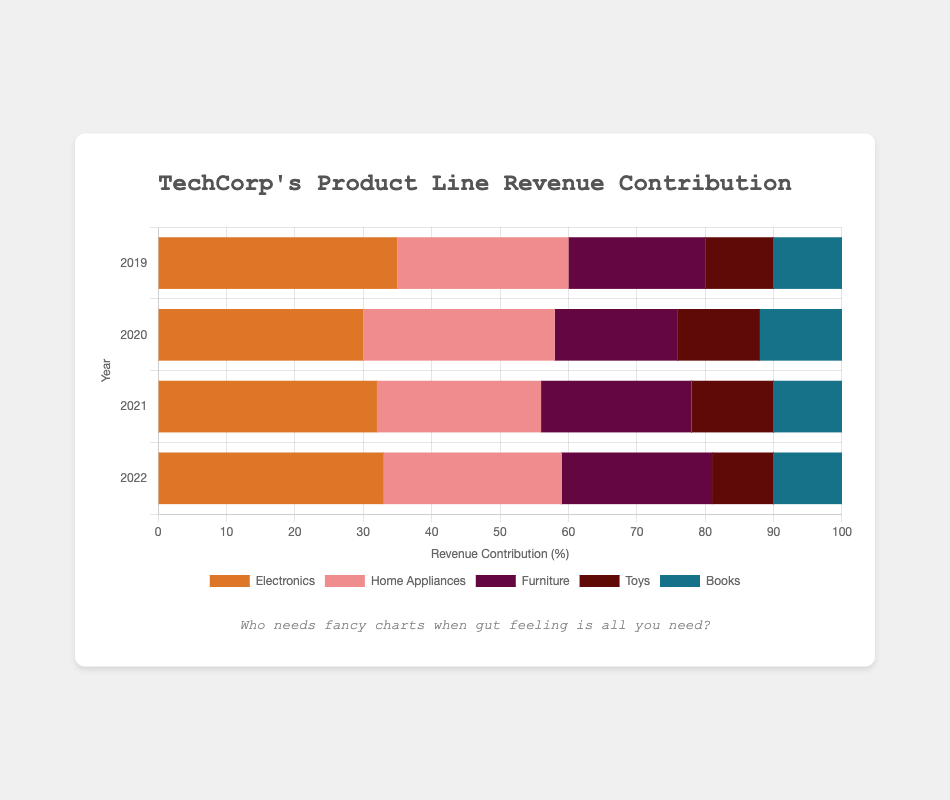Which product line had the highest revenue contribution in 2019? The figure shows that in 2019, the Electronics product line had the highest revenue contribution. This can be identified by the length of the bar representing Electronics in 2019, which is the longest among all product lines.
Answer: Electronics Which year had the highest total revenue contribution from the Toys product line? By examining the length of the Toys bar across the years, 2020 and 2021 have the longest bars at 12%. Since the values are equal, both years had the highest contribution for Toys.
Answer: 2020 and 2021 What is the total revenue contribution of Electronics and Furniture product lines in 2022? To find the total revenue contribution for 2022, add the percentage contributions of Electronics (33%) and Furniture (22%) for 2022. This equals 33 + 22 = 55%.
Answer: 55% Which product line experienced an increase in revenue contribution from 2019 to 2020? By comparing the lengths of bars for each product line from 2019 to 2020, Home Appliances shows an increase from 25% to 28%, and Toys from 10% to 12%.
Answer: Home Appliances and Toys In which year did the Home Appliances product line contribute a higher percentage than the Furniture product line? Checking each year's bars for Home Appliances and Furniture, Home Appliances contributed more than Furniture in 2020 and 2022: 28% vs. 18% for 2020 and 26% vs. 22% for 2022.
Answer: 2020 and 2022 What is the average revenue contribution of Books from 2019 to 2022? To calculate the average, sum the contributions for Books across the years (10% in 2019, 12% in 2020, 10% in 2021, and 10% in 2022). The total is 10 + 12 + 10 + 10 = 42. Divide by the number of years (4). The average is 42 / 4 = 10.5%.
Answer: 10.5% Which product line had the most stable revenue contribution percentage from 2019 to 2022, meaning the smallest changes year over year? By observing each bar's changes, the Books product line shows the most stability: it remains close to 10% throughout the four years (10%, 12%, 10%, 10%).
Answer: Books Compare the combined revenue contribution of Books and Furniture in 2019 to Electronics alone in 2021. Which is higher? Summing Books and Furniture in 2019: 10% + 20% = 30%. Electronics alone in 2021 is 32%. Comparing 30% and 32%, Electronics in 2021 has a higher contribution.
Answer: Electronics in 2021 Which product line has the most significant drop in revenue contribution between any two consecutive years? By examining the bars year by year, Electronics from 2019 to 2020 had the largest drop: from 35% to 30%, which is a 5% decrease.
Answer: Electronics (2019 to 2020) How did the revenue contribution of Home Appliances change from 2019 to 2021? For Home Appliances, examine the percentages from 2019 (25%), 2020 (28%), and 2021 (24%). From 2019 to 2020, it increased by 3%, then decreased by 4% from 2020 to 2021. The net change from 2019 to 2021 is -1%.
Answer: Decreased by 1% 